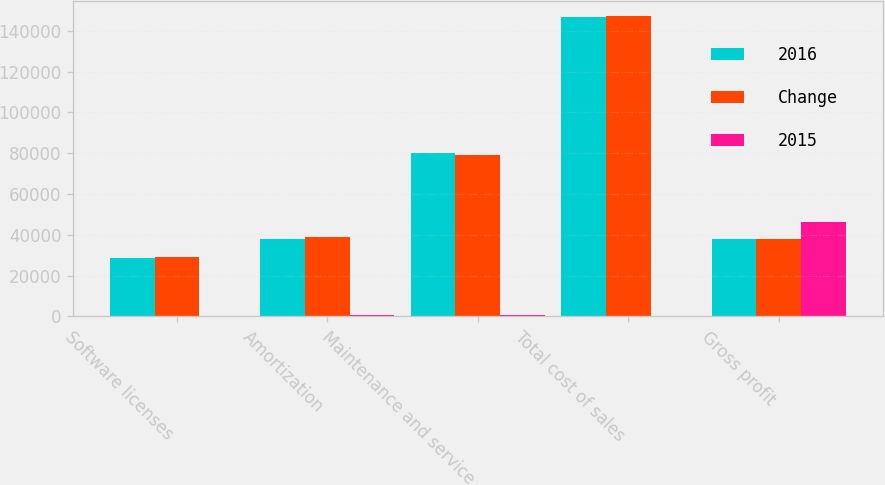<chart> <loc_0><loc_0><loc_500><loc_500><stacked_bar_chart><ecel><fcel>Software licenses<fcel>Amortization<fcel>Maintenance and service<fcel>Total cost of sales<fcel>Gross profit<nl><fcel>2016<fcel>28860<fcel>38092<fcel>79908<fcel>146860<fcel>38092<nl><fcel>Change<fcel>29105<fcel>38755<fcel>79386<fcel>147246<fcel>38092<nl><fcel>2015<fcel>245<fcel>663<fcel>522<fcel>386<fcel>46098<nl></chart> 